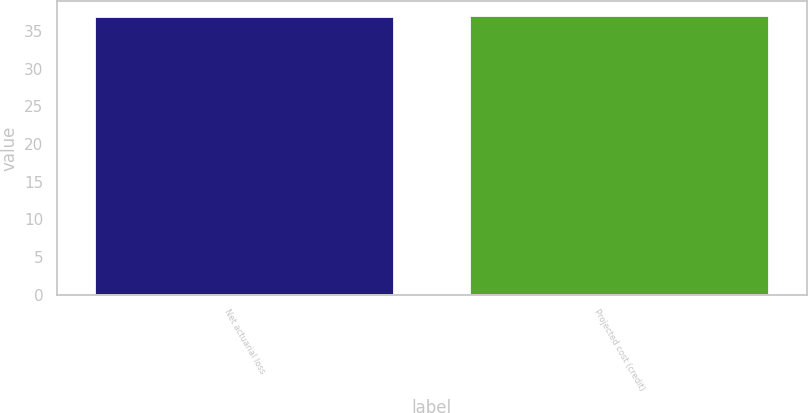Convert chart to OTSL. <chart><loc_0><loc_0><loc_500><loc_500><bar_chart><fcel>Net actuarial loss<fcel>Projected cost (credit)<nl><fcel>37<fcel>37.1<nl></chart> 